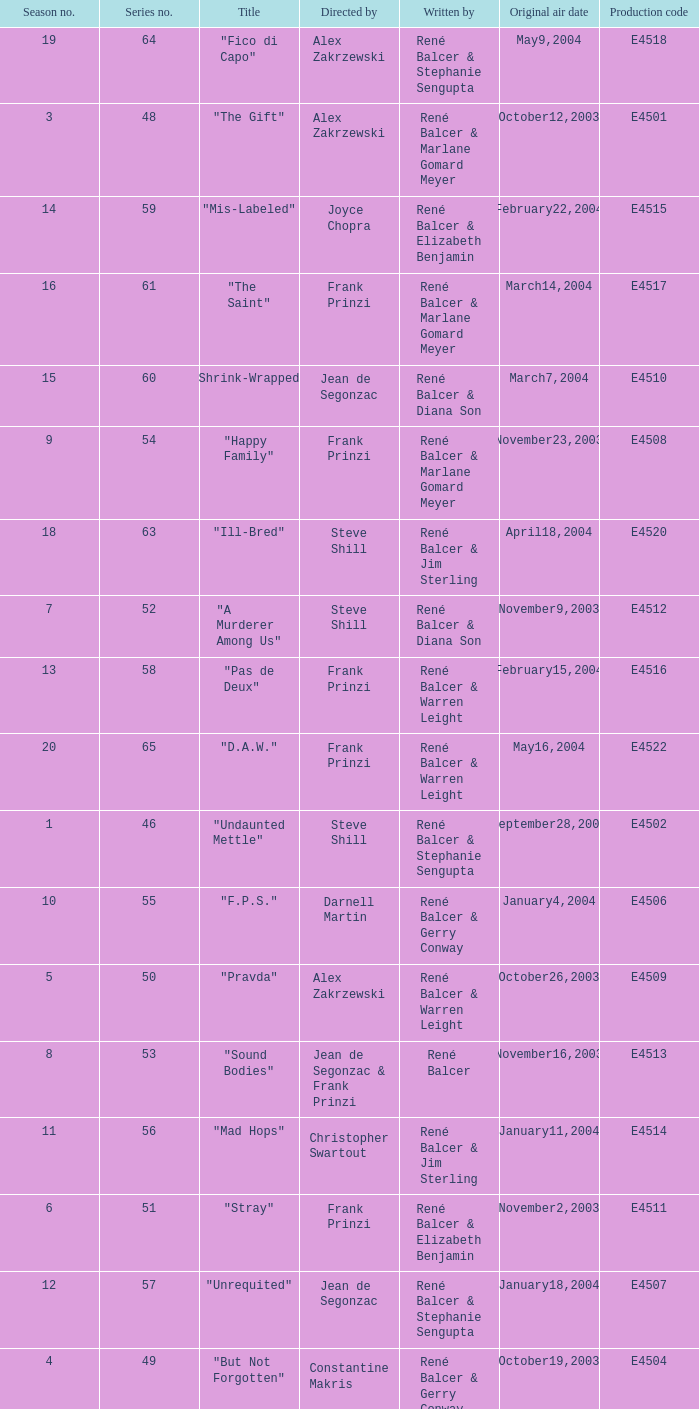Who wrote the episode with e4515 as the production code? René Balcer & Elizabeth Benjamin. 